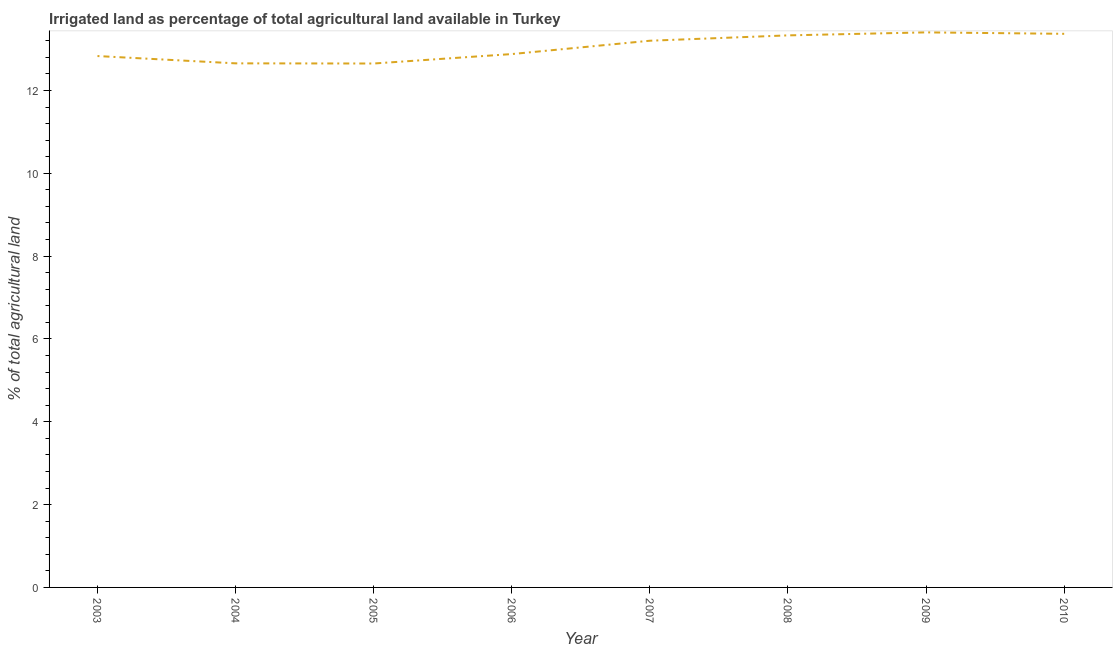What is the percentage of agricultural irrigated land in 2009?
Provide a short and direct response. 13.4. Across all years, what is the maximum percentage of agricultural irrigated land?
Offer a very short reply. 13.4. Across all years, what is the minimum percentage of agricultural irrigated land?
Keep it short and to the point. 12.65. In which year was the percentage of agricultural irrigated land maximum?
Offer a very short reply. 2009. What is the sum of the percentage of agricultural irrigated land?
Offer a terse response. 104.32. What is the difference between the percentage of agricultural irrigated land in 2003 and 2010?
Keep it short and to the point. -0.54. What is the average percentage of agricultural irrigated land per year?
Offer a terse response. 13.04. What is the median percentage of agricultural irrigated land?
Your response must be concise. 13.04. What is the ratio of the percentage of agricultural irrigated land in 2006 to that in 2008?
Keep it short and to the point. 0.97. Is the percentage of agricultural irrigated land in 2005 less than that in 2007?
Give a very brief answer. Yes. What is the difference between the highest and the second highest percentage of agricultural irrigated land?
Your response must be concise. 0.03. What is the difference between the highest and the lowest percentage of agricultural irrigated land?
Provide a short and direct response. 0.75. Does the graph contain any zero values?
Your answer should be compact. No. Does the graph contain grids?
Keep it short and to the point. No. What is the title of the graph?
Your answer should be very brief. Irrigated land as percentage of total agricultural land available in Turkey. What is the label or title of the X-axis?
Your answer should be compact. Year. What is the label or title of the Y-axis?
Keep it short and to the point. % of total agricultural land. What is the % of total agricultural land of 2003?
Provide a short and direct response. 12.83. What is the % of total agricultural land of 2004?
Provide a succinct answer. 12.65. What is the % of total agricultural land of 2005?
Your answer should be compact. 12.65. What is the % of total agricultural land in 2006?
Provide a short and direct response. 12.88. What is the % of total agricultural land of 2007?
Ensure brevity in your answer.  13.2. What is the % of total agricultural land in 2008?
Your answer should be compact. 13.33. What is the % of total agricultural land of 2009?
Your answer should be very brief. 13.4. What is the % of total agricultural land in 2010?
Provide a short and direct response. 13.37. What is the difference between the % of total agricultural land in 2003 and 2004?
Your answer should be very brief. 0.18. What is the difference between the % of total agricultural land in 2003 and 2005?
Your answer should be compact. 0.18. What is the difference between the % of total agricultural land in 2003 and 2006?
Your answer should be very brief. -0.05. What is the difference between the % of total agricultural land in 2003 and 2007?
Provide a succinct answer. -0.37. What is the difference between the % of total agricultural land in 2003 and 2008?
Offer a terse response. -0.5. What is the difference between the % of total agricultural land in 2003 and 2009?
Provide a short and direct response. -0.57. What is the difference between the % of total agricultural land in 2003 and 2010?
Your answer should be compact. -0.54. What is the difference between the % of total agricultural land in 2004 and 2005?
Offer a very short reply. 0. What is the difference between the % of total agricultural land in 2004 and 2006?
Offer a very short reply. -0.22. What is the difference between the % of total agricultural land in 2004 and 2007?
Your answer should be compact. -0.55. What is the difference between the % of total agricultural land in 2004 and 2008?
Offer a very short reply. -0.68. What is the difference between the % of total agricultural land in 2004 and 2009?
Ensure brevity in your answer.  -0.75. What is the difference between the % of total agricultural land in 2004 and 2010?
Your response must be concise. -0.71. What is the difference between the % of total agricultural land in 2005 and 2006?
Your answer should be compact. -0.23. What is the difference between the % of total agricultural land in 2005 and 2007?
Offer a very short reply. -0.55. What is the difference between the % of total agricultural land in 2005 and 2008?
Your response must be concise. -0.68. What is the difference between the % of total agricultural land in 2005 and 2009?
Keep it short and to the point. -0.75. What is the difference between the % of total agricultural land in 2005 and 2010?
Keep it short and to the point. -0.72. What is the difference between the % of total agricultural land in 2006 and 2007?
Offer a very short reply. -0.32. What is the difference between the % of total agricultural land in 2006 and 2008?
Provide a succinct answer. -0.45. What is the difference between the % of total agricultural land in 2006 and 2009?
Offer a terse response. -0.52. What is the difference between the % of total agricultural land in 2006 and 2010?
Keep it short and to the point. -0.49. What is the difference between the % of total agricultural land in 2007 and 2008?
Provide a succinct answer. -0.13. What is the difference between the % of total agricultural land in 2007 and 2009?
Ensure brevity in your answer.  -0.2. What is the difference between the % of total agricultural land in 2007 and 2010?
Offer a terse response. -0.17. What is the difference between the % of total agricultural land in 2008 and 2009?
Provide a short and direct response. -0.07. What is the difference between the % of total agricultural land in 2008 and 2010?
Offer a very short reply. -0.04. What is the difference between the % of total agricultural land in 2009 and 2010?
Provide a succinct answer. 0.03. What is the ratio of the % of total agricultural land in 2003 to that in 2004?
Make the answer very short. 1.01. What is the ratio of the % of total agricultural land in 2003 to that in 2005?
Provide a short and direct response. 1.01. What is the ratio of the % of total agricultural land in 2003 to that in 2006?
Your answer should be compact. 1. What is the ratio of the % of total agricultural land in 2003 to that in 2007?
Make the answer very short. 0.97. What is the ratio of the % of total agricultural land in 2003 to that in 2009?
Offer a terse response. 0.96. What is the ratio of the % of total agricultural land in 2003 to that in 2010?
Your answer should be compact. 0.96. What is the ratio of the % of total agricultural land in 2004 to that in 2005?
Your answer should be very brief. 1. What is the ratio of the % of total agricultural land in 2004 to that in 2006?
Offer a terse response. 0.98. What is the ratio of the % of total agricultural land in 2004 to that in 2008?
Keep it short and to the point. 0.95. What is the ratio of the % of total agricultural land in 2004 to that in 2009?
Make the answer very short. 0.94. What is the ratio of the % of total agricultural land in 2004 to that in 2010?
Provide a succinct answer. 0.95. What is the ratio of the % of total agricultural land in 2005 to that in 2007?
Make the answer very short. 0.96. What is the ratio of the % of total agricultural land in 2005 to that in 2008?
Make the answer very short. 0.95. What is the ratio of the % of total agricultural land in 2005 to that in 2009?
Your answer should be very brief. 0.94. What is the ratio of the % of total agricultural land in 2005 to that in 2010?
Offer a very short reply. 0.95. What is the ratio of the % of total agricultural land in 2006 to that in 2007?
Keep it short and to the point. 0.98. What is the ratio of the % of total agricultural land in 2007 to that in 2008?
Make the answer very short. 0.99. What is the ratio of the % of total agricultural land in 2008 to that in 2010?
Your answer should be very brief. 1. 